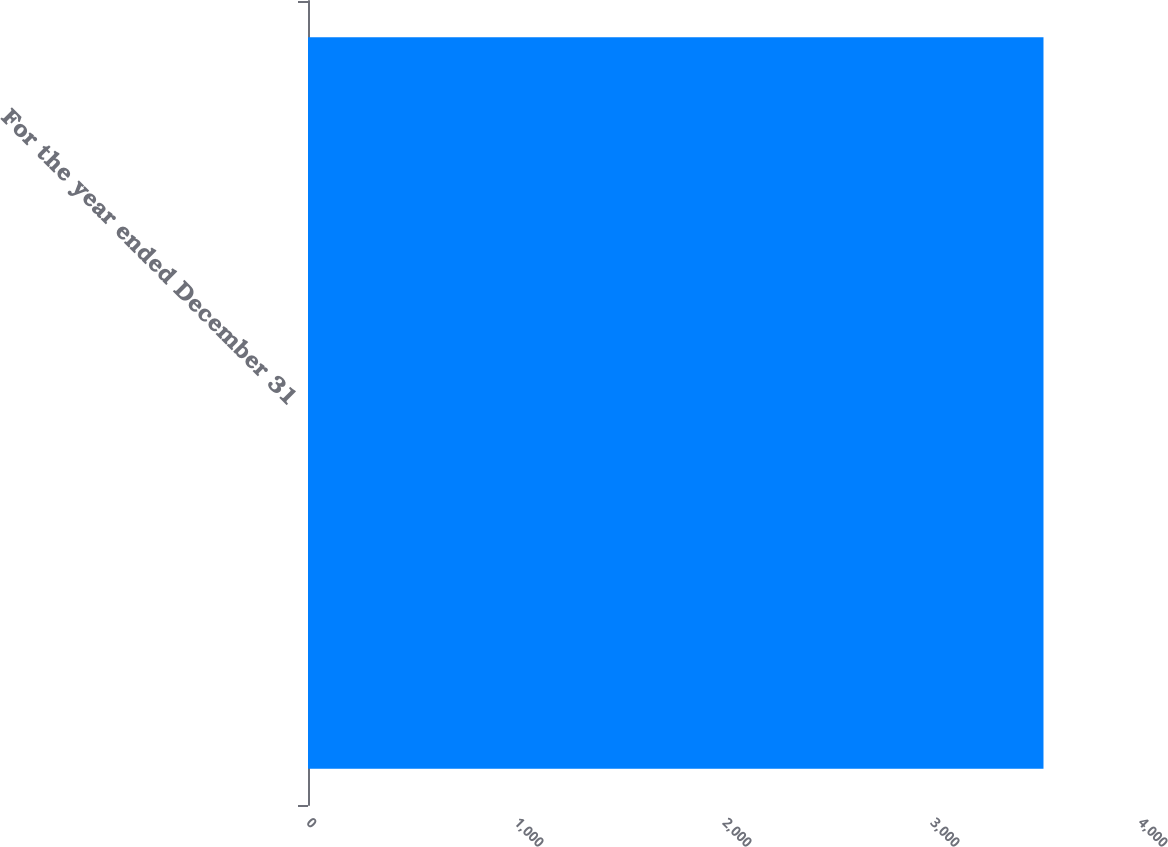Convert chart to OTSL. <chart><loc_0><loc_0><loc_500><loc_500><bar_chart><fcel>For the year ended December 31<nl><fcel>3536<nl></chart> 